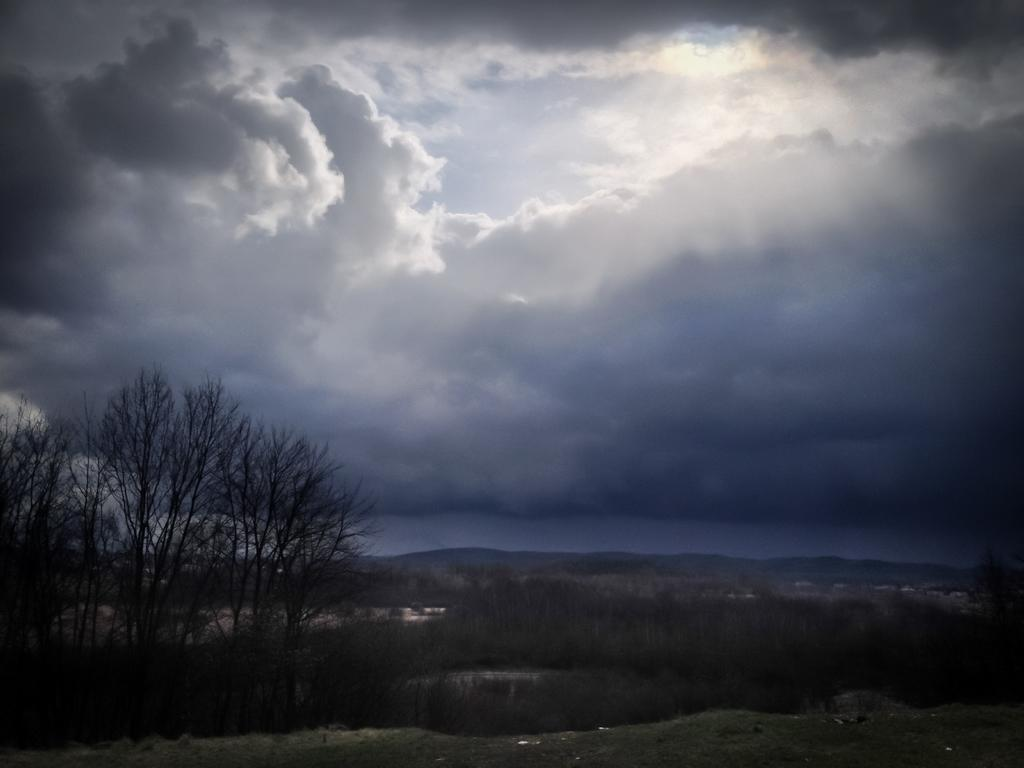What type of surface is visible in the image? There is ground visible in the image. What type of vegetation can be seen in the image? There are plants and trees in the image. What is visible in the background of the image? The sky is visible in the background of the image. What can be seen in the sky? There are clouds in the sky. How many eyes can be seen on the goose in the image? There is no goose present in the image, so there are no eyes to count. What type of wax is used to create the plants in the image? The plants in the image are not made of wax; they are real plants. 